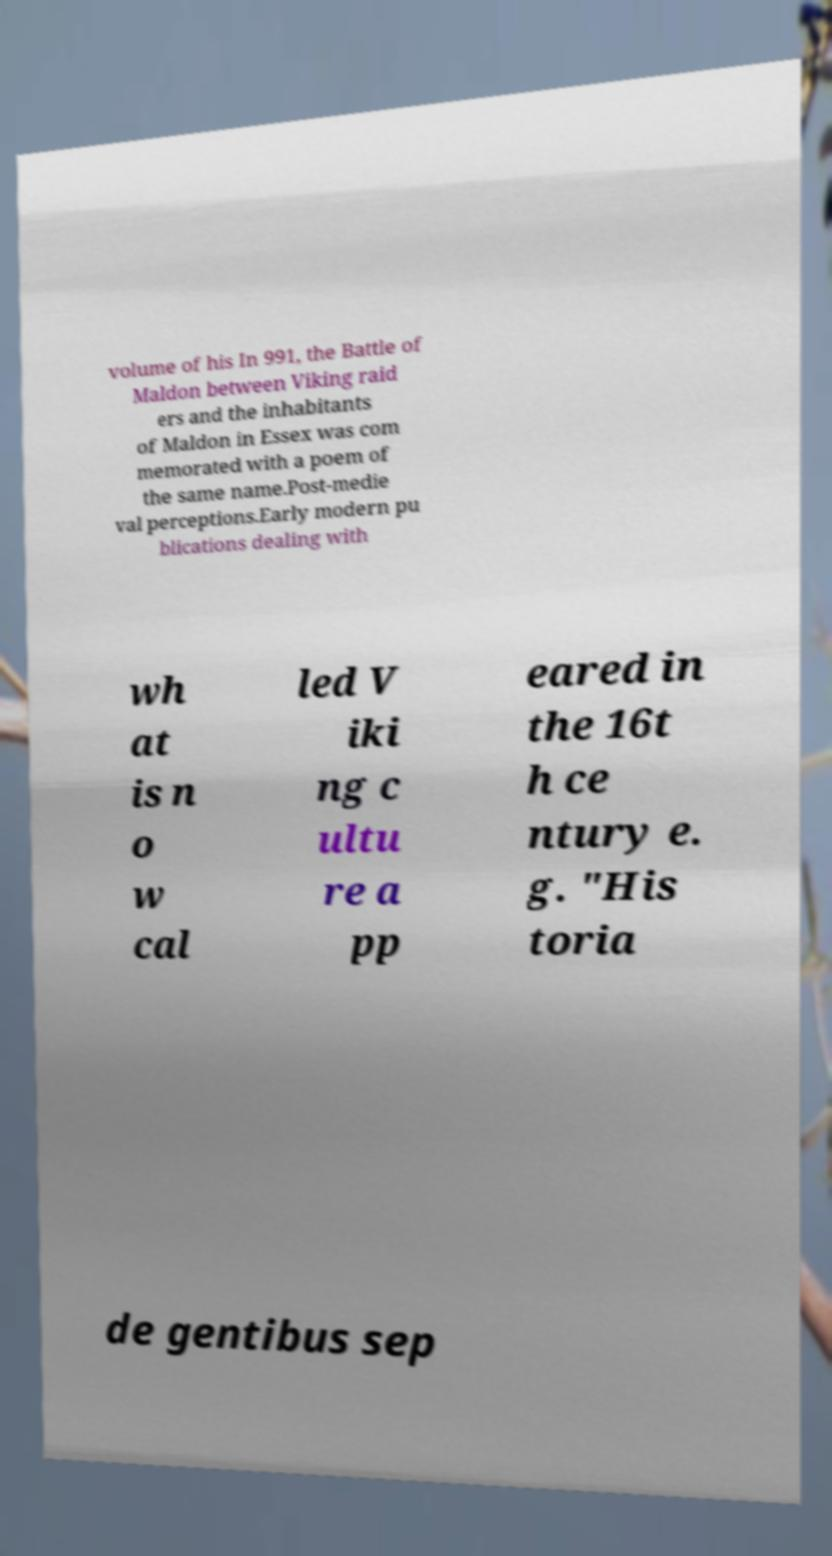Can you accurately transcribe the text from the provided image for me? volume of his In 991, the Battle of Maldon between Viking raid ers and the inhabitants of Maldon in Essex was com memorated with a poem of the same name.Post-medie val perceptions.Early modern pu blications dealing with wh at is n o w cal led V iki ng c ultu re a pp eared in the 16t h ce ntury e. g. "His toria de gentibus sep 